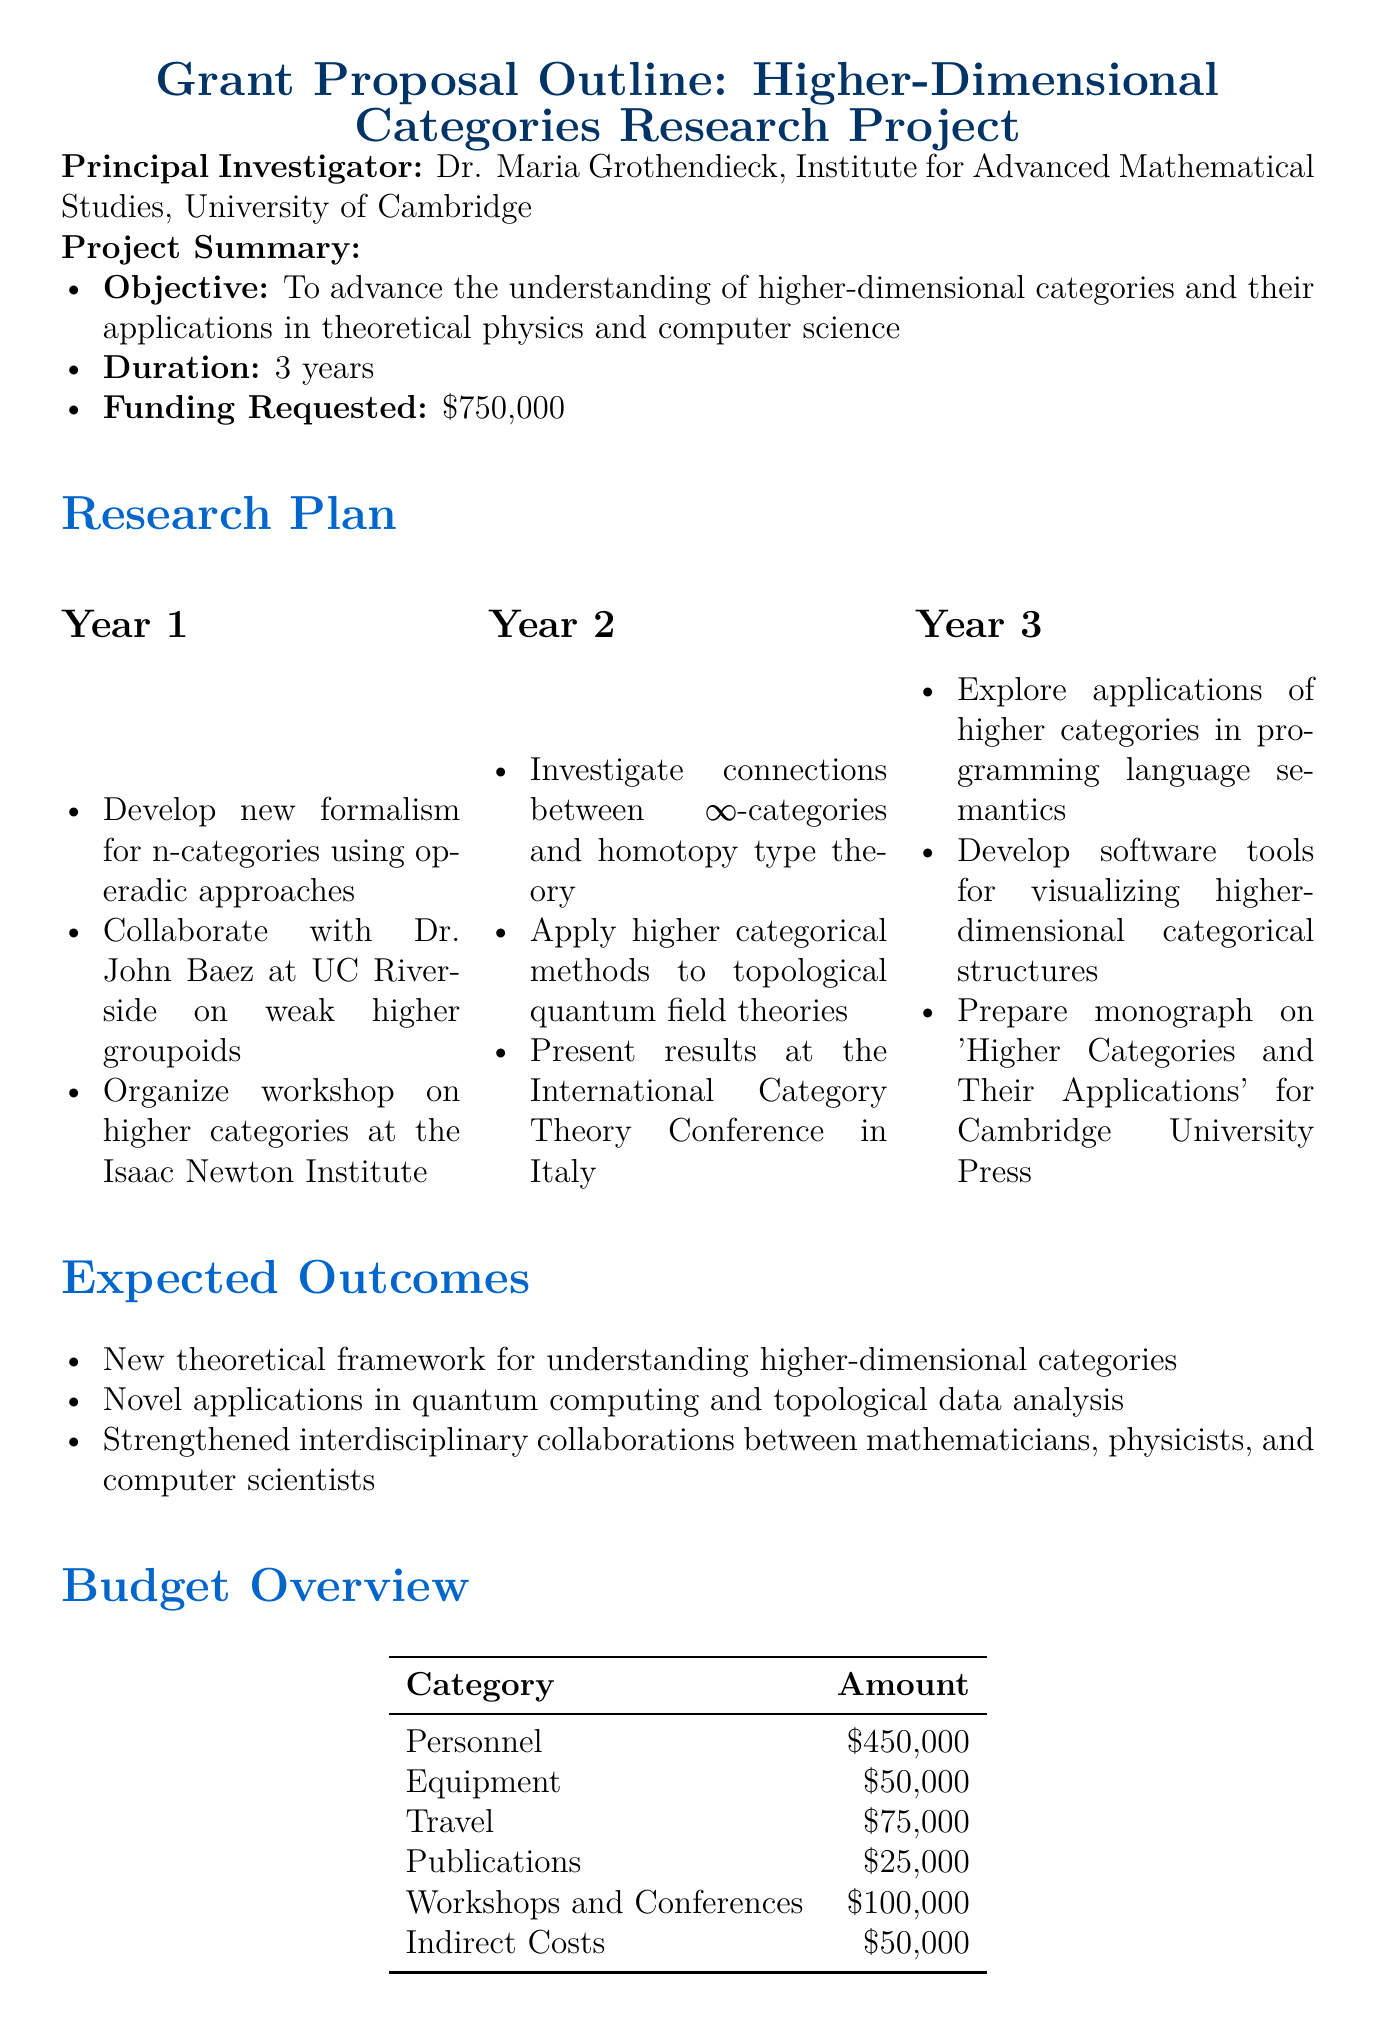What is the funding requested for the project? The funding requested is explicitly stated in the project summary of the document.
Answer: $750,000 Who is the principal investigator? The document specifies the name and affiliation of the principal investigator in the introduction.
Answer: Dr. Maria Grothendieck What is the duration of the project? The duration is outlined in the project summary, providing explicit information on the timeline of the project.
Answer: 3 years Which collaborators are mentioned in the proposal? The section on collaborators lists the names and affiliations of individuals involved in the research project.
Answer: Dr. Emily Riehl, Dr. Dominic Verity What is one expected outcome of the research project? The expected outcomes section lists several results that are anticipated from the research, providing insight into the goals of the project.
Answer: New theoretical framework for understanding higher-dimensional categories In which year is the workshop on higher categories planned? The activities for Year 1 outline the plans for organizing a workshop, indicating the specific timing of this event within the project's timeline.
Answer: Year 1 What is the largest category in the budget overview? The budget overview provides detailed amounts for different categories, making it easy to identify the one with the highest allocation.
Answer: Personnel What facility is available for collaboration? The facilities and resources section lists various resources available for the research team, including specific locations for collaborative work.
Answer: Isaac Newton Institute for Mathematical Sciences 